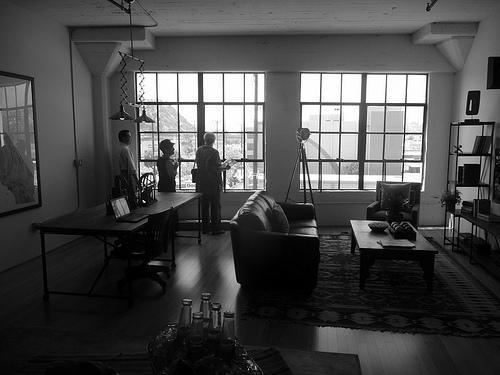How many couches are in the image?
Give a very brief answer. 1. How many people are in the image?
Give a very brief answer. 3. How many windows are in the image?
Give a very brief answer. 2. How many people are sitting on the sofa?
Give a very brief answer. 0. 